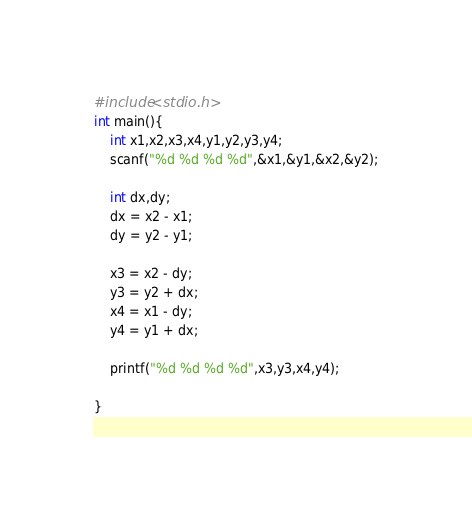Convert code to text. <code><loc_0><loc_0><loc_500><loc_500><_C_>#include<stdio.h>
int main(){
	int x1,x2,x3,x4,y1,y2,y3,y4;
	scanf("%d %d %d %d",&x1,&y1,&x2,&y2);
	
	int dx,dy;
	dx = x2 - x1;
	dy = y2 - y1;
	
	x3 = x2 - dy;
	y3 = y2 + dx;
	x4 = x1 - dy;
	y4 = y1 + dx;
	
	printf("%d %d %d %d",x3,y3,x4,y4);
	
}</code> 